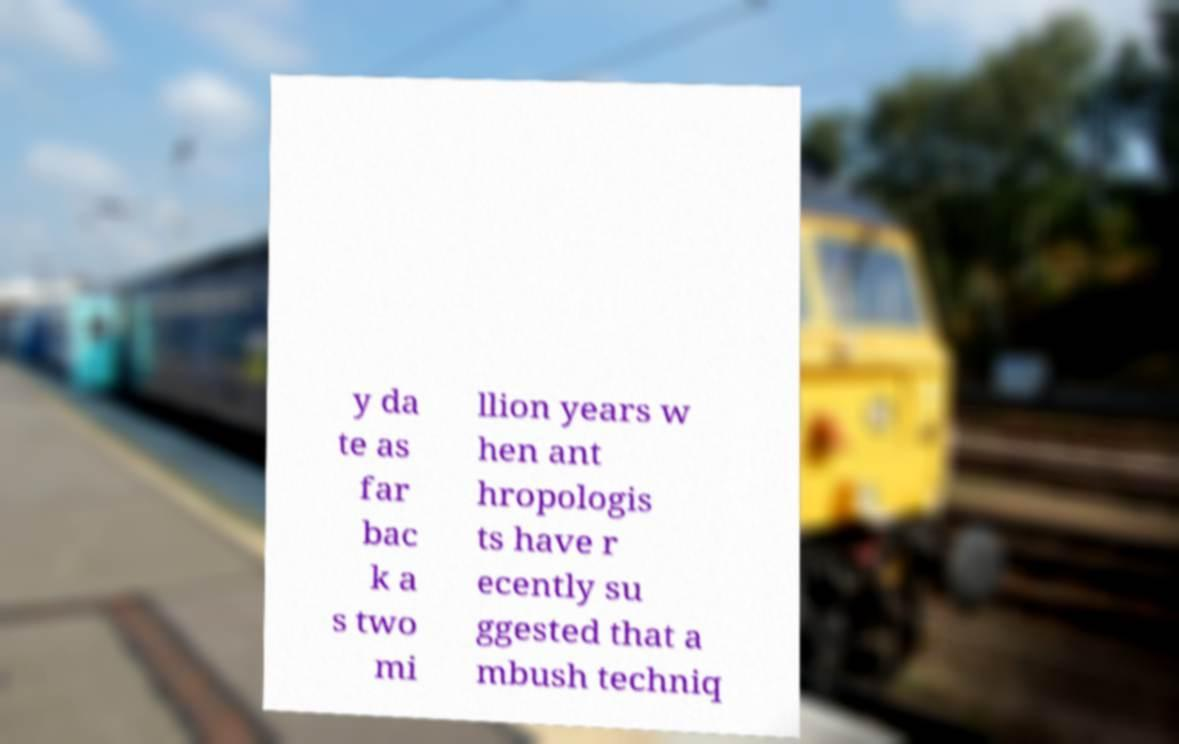What messages or text are displayed in this image? I need them in a readable, typed format. y da te as far bac k a s two mi llion years w hen ant hropologis ts have r ecently su ggested that a mbush techniq 